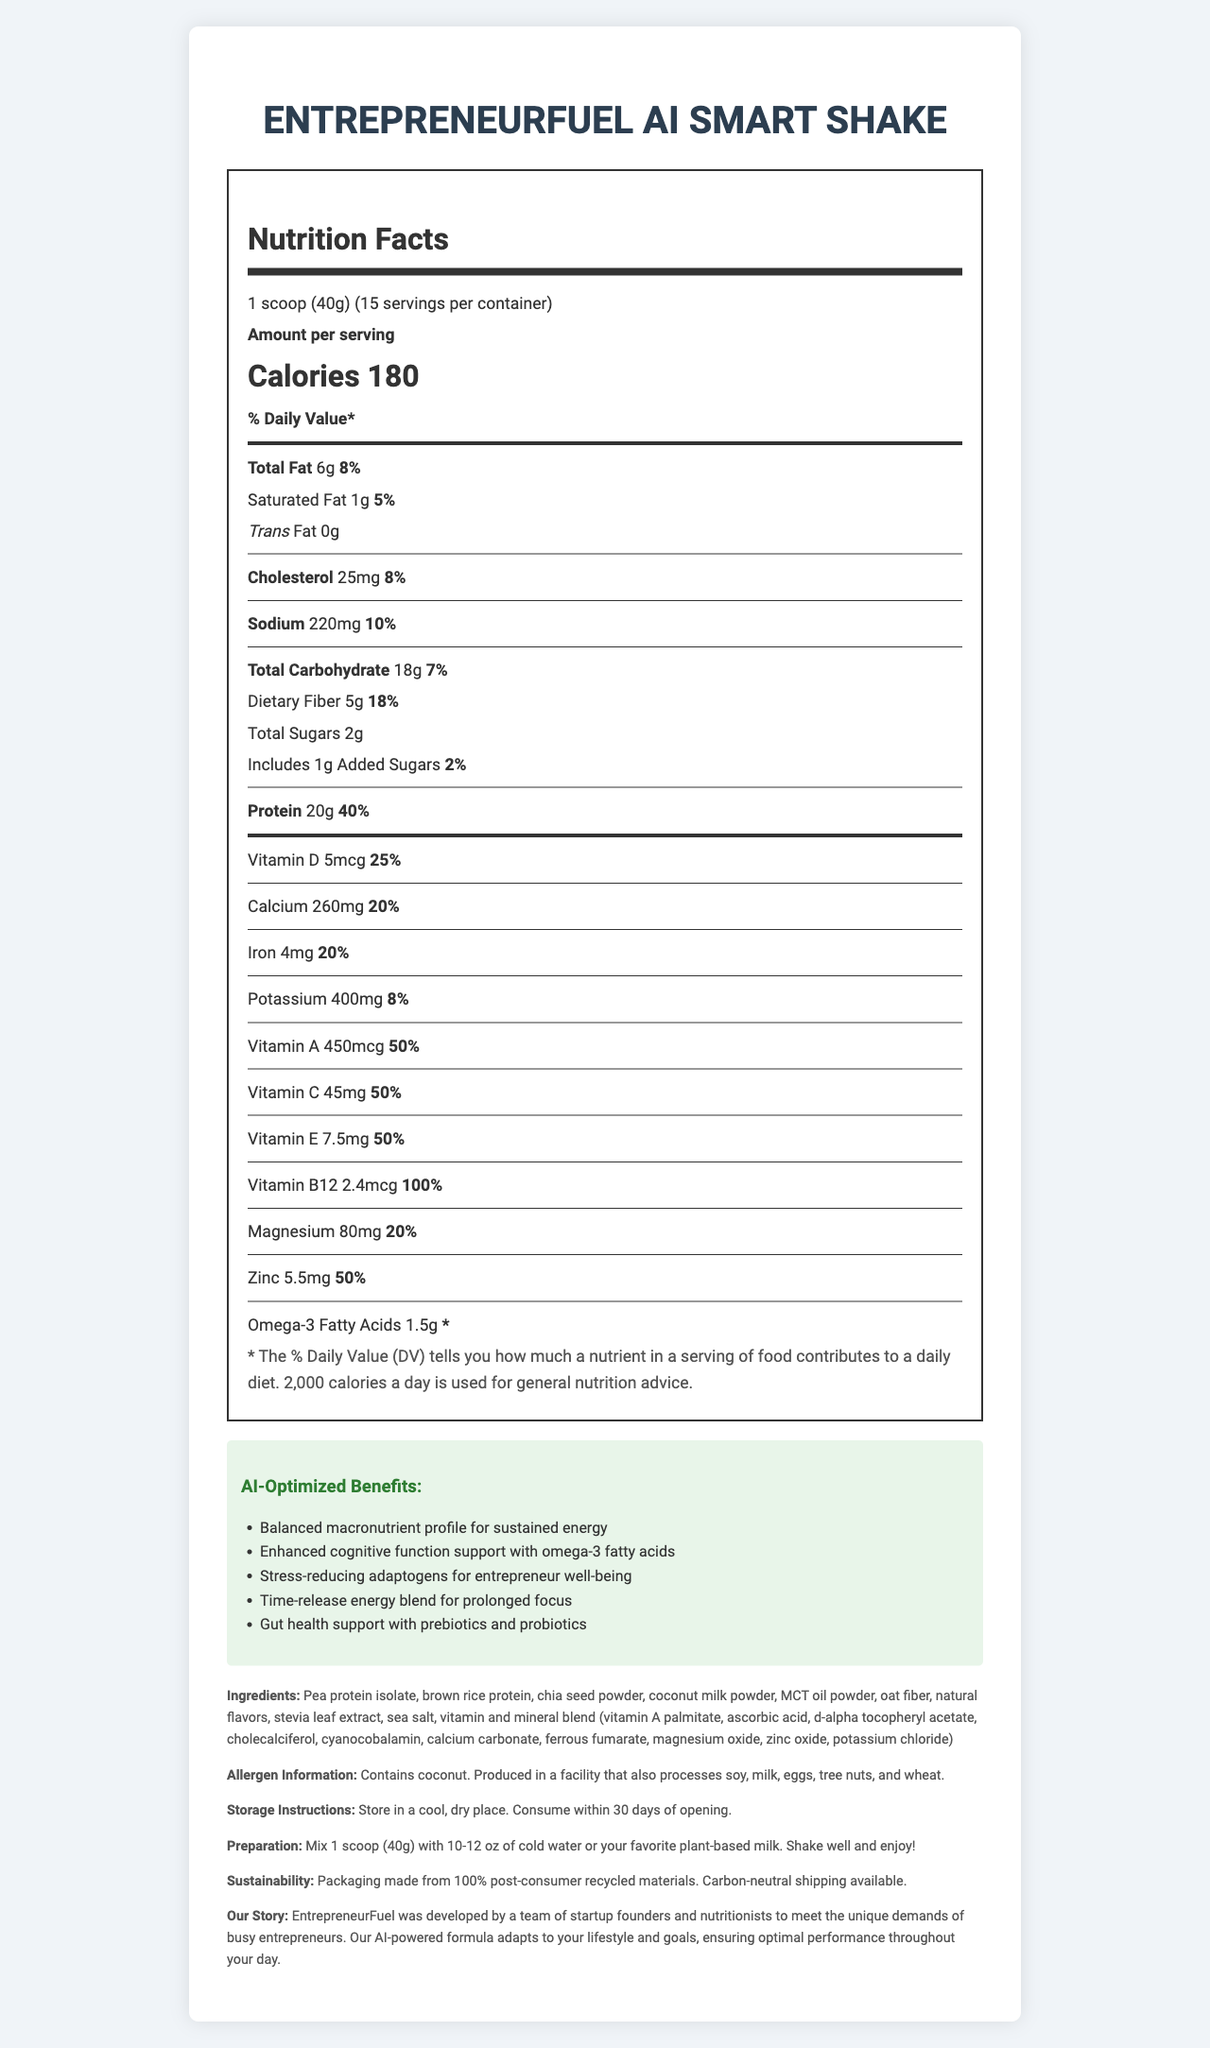Who is the target audience for the EntrepreneurFuel AI Smart Shake? The brand story indicates that the product is designed to meet the unique demands of busy entrepreneurs.
Answer: Busy entrepreneurs How much protein is in one serving? The nutrition facts state that each serving contains 20g of protein.
Answer: 20g What is the percentage of the daily value for Vitamin B12 in one serving? The label indicates that one serving provides 100% of the daily value for Vitamin B12.
Answer: 100% Does the product contain any allergens? The allergen information section explicitly lists this information.
Answer: Yes, it contains coconut and is produced in a facility that also processes soy, milk, eggs, tree nuts, and wheat. How many servings are there per container? The nutrition facts state that there are 15 servings per container.
Answer: 15 Where should the product be stored? The storage instructions specify to store the product in a cool, dry place.
Answer: In a cool, dry place Which claim is NOT listed as an AI-optimized benefit for the EntrepreneurFuel AI Smart Shake? A. Balanced macronutrient profile B. Enhanced cognitive function support C. Muscle growth support D. Gut health support The AI-optimized claims listed include balanced macronutrient profile, enhanced cognitive function support, stress-reducing adaptogens, time-release energy blend, and gut health support, but not muscle growth support.
Answer: C. Muscle growth support The product provides prolonged focus through its: A. Balanced macronutrient profile B. Time-release energy blend C. Omega-3 fatty acids D. Adaptogens The AI-optimized claims mention that the time-release energy blend provides prolonged focus.
Answer: B. Time-release energy blend Does the product include any added sugars? The nutrition facts show that there is 1g of added sugars.
Answer: Yes Summarize the primary purpose and key features of the EntrepreneurFuel AI Smart Shake. The document details the product's purpose, serving size, nutritional content, AI-benefits, ingredients, allergen information, and storage and preparation instructions.
Answer: The EntrepreneurFuel AI Smart Shake is designed for busy entrepreneurs to provide a balanced, nutrient-dense meal replacement optimized by AI. Key features include high protein content, support for cognitive function, stress reduction, prolonged focus, and gut health. It contains 20g of protein, 18g of carbohydrates, 6g of fat per serving, and various vitamins and minerals. The product is allergen-free except for coconut and is produced in a facility that processes other allergens. What type of fat is listed as "0g" in the nutritional information? The nutrition facts label indicates that the trans fat content is 0g.
Answer: Trans Fat How much dietary fiber does one serving provide? The nutrition facts state that each serving includes 5g of dietary fiber.
Answer: 5g Is the product suitable for vegans? The document does not provide enough information about whether all ingredients are vegan-friendly.
Answer: Cannot be determined What are the daily values percentages for Vitamin A and Vitamin C? The nutrition facts indicate that both Vitamin A and Vitamin C provide 50% of their respective daily values per serving.
Answer: 50% for both 